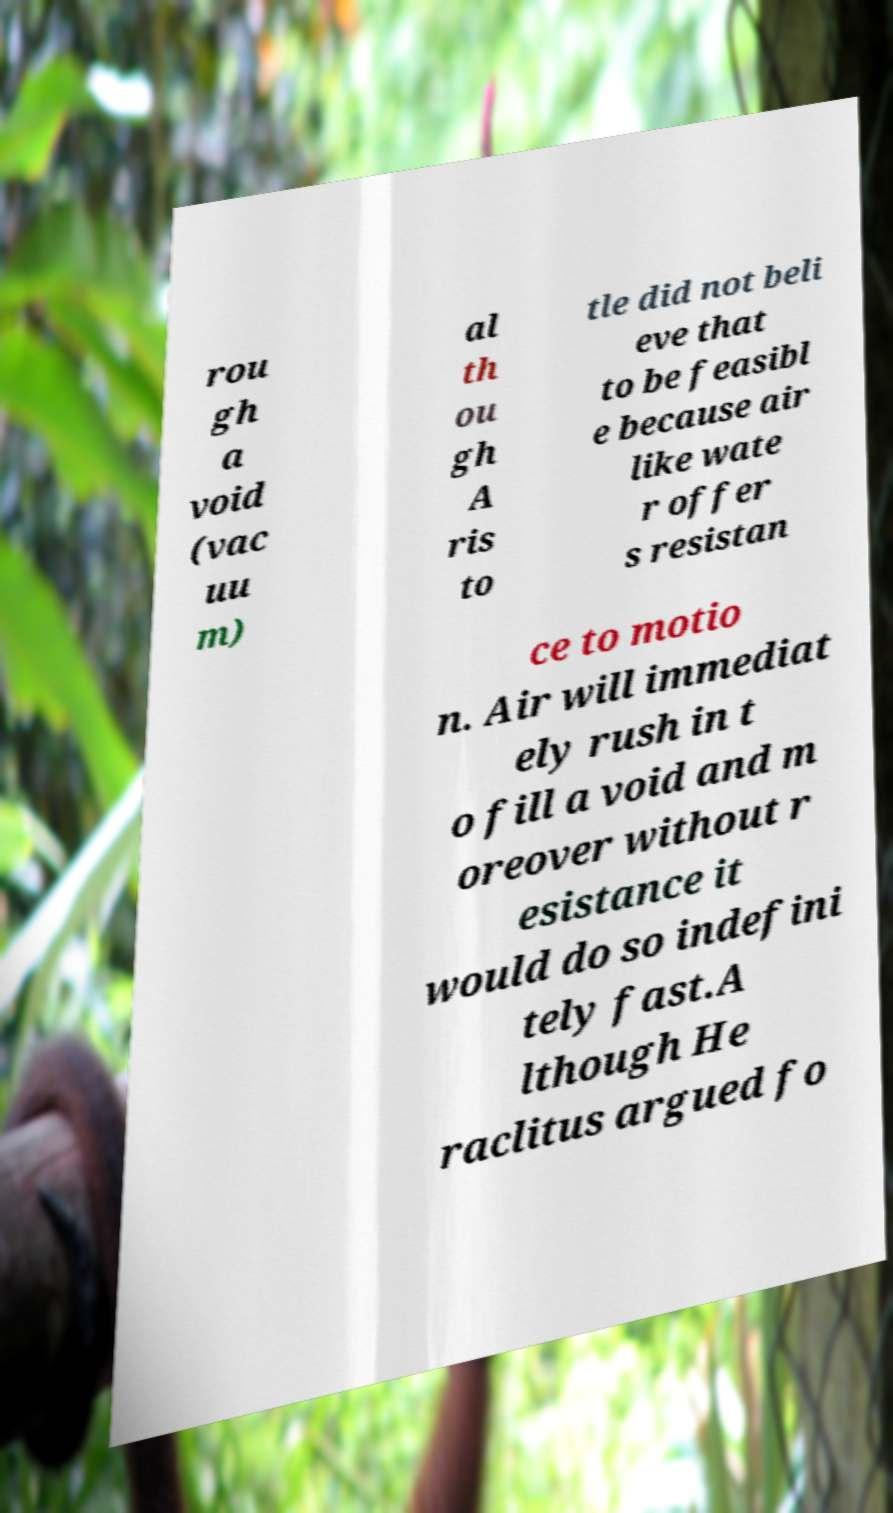Could you assist in decoding the text presented in this image and type it out clearly? rou gh a void (vac uu m) al th ou gh A ris to tle did not beli eve that to be feasibl e because air like wate r offer s resistan ce to motio n. Air will immediat ely rush in t o fill a void and m oreover without r esistance it would do so indefini tely fast.A lthough He raclitus argued fo 